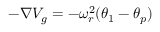<formula> <loc_0><loc_0><loc_500><loc_500>- \nabla V _ { g } = - \omega _ { r } ^ { 2 } ( \theta _ { 1 } - \theta _ { p } )</formula> 